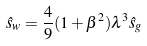Convert formula to latex. <formula><loc_0><loc_0><loc_500><loc_500>\hat { s } _ { w } = \frac { 4 } { 9 } ( 1 + \beta ^ { 2 } ) \lambda ^ { 3 } \hat { s } _ { g }</formula> 